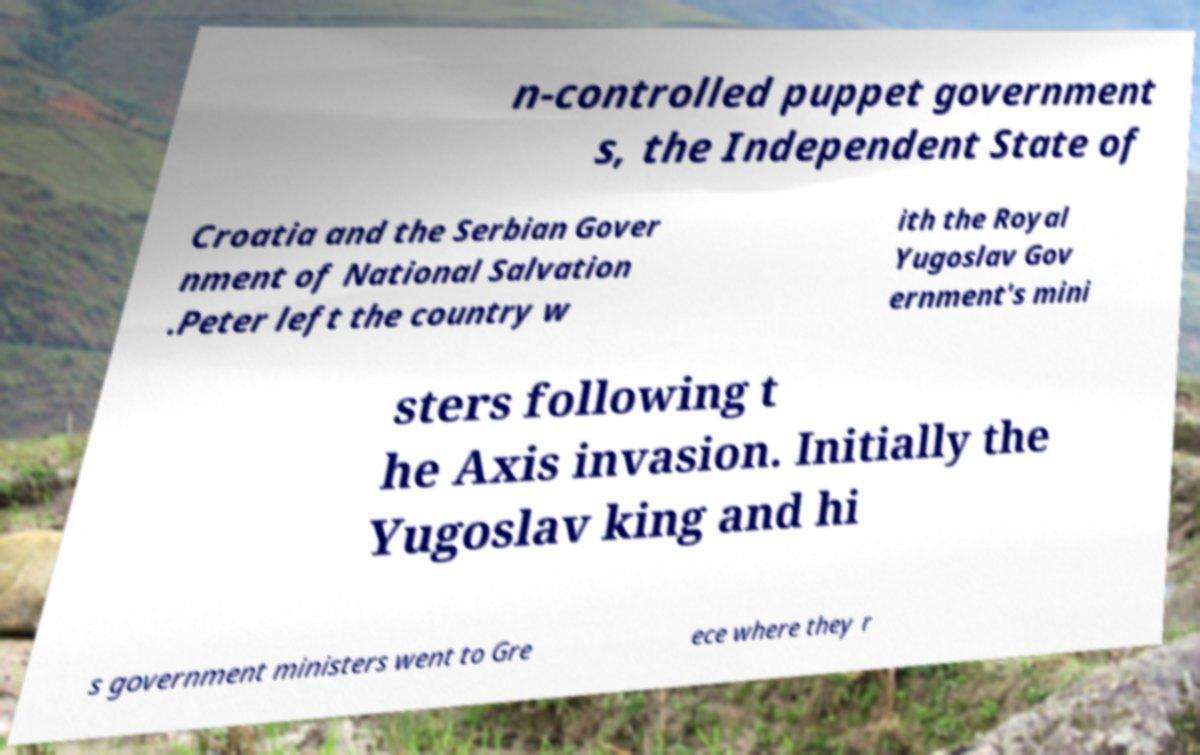Please identify and transcribe the text found in this image. n-controlled puppet government s, the Independent State of Croatia and the Serbian Gover nment of National Salvation .Peter left the country w ith the Royal Yugoslav Gov ernment's mini sters following t he Axis invasion. Initially the Yugoslav king and hi s government ministers went to Gre ece where they r 